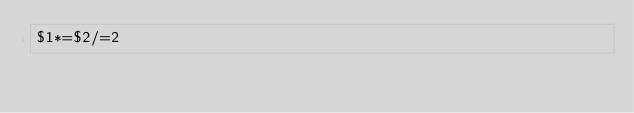Convert code to text. <code><loc_0><loc_0><loc_500><loc_500><_Awk_>$1*=$2/=2</code> 